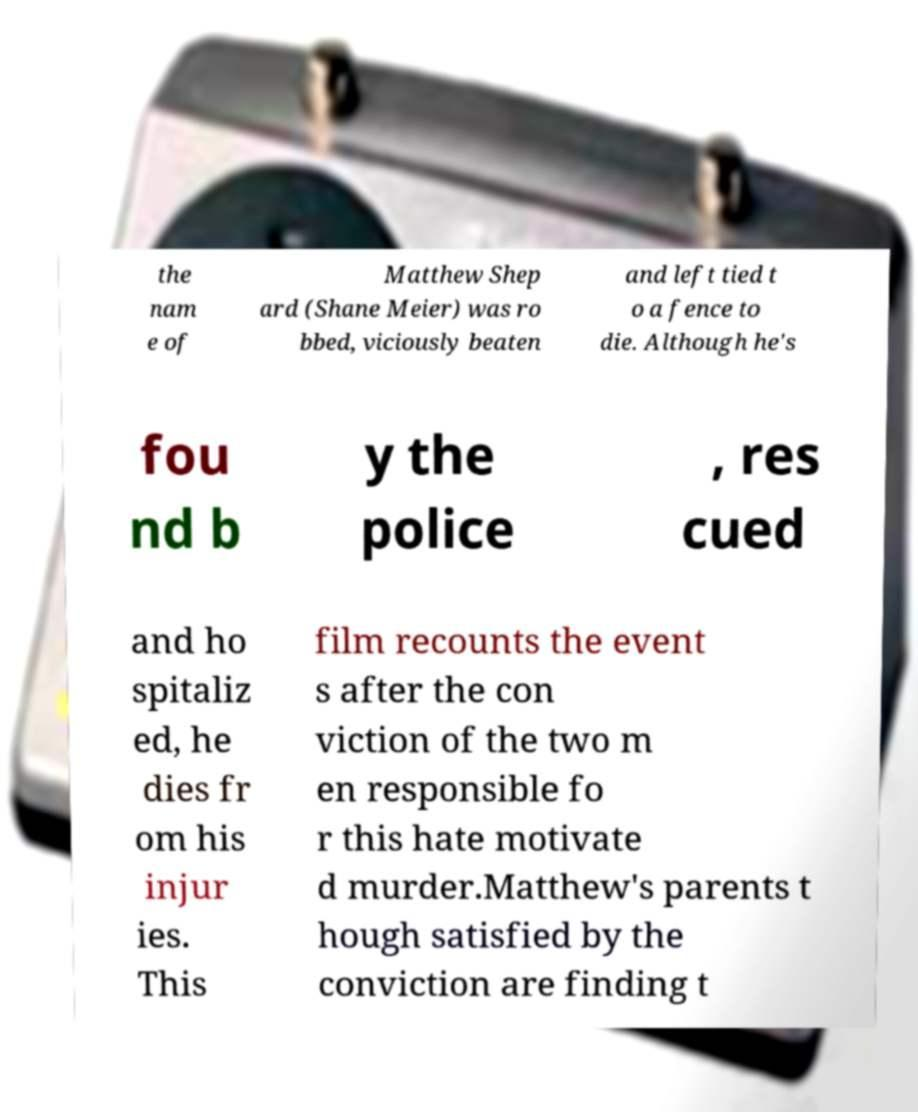Can you read and provide the text displayed in the image?This photo seems to have some interesting text. Can you extract and type it out for me? the nam e of Matthew Shep ard (Shane Meier) was ro bbed, viciously beaten and left tied t o a fence to die. Although he's fou nd b y the police , res cued and ho spitaliz ed, he dies fr om his injur ies. This film recounts the event s after the con viction of the two m en responsible fo r this hate motivate d murder.Matthew's parents t hough satisfied by the conviction are finding t 